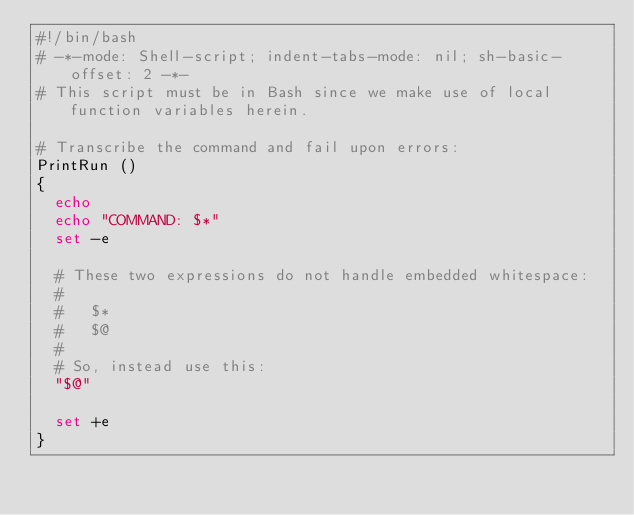<code> <loc_0><loc_0><loc_500><loc_500><_Bash_>#!/bin/bash
# -*-mode: Shell-script; indent-tabs-mode: nil; sh-basic-offset: 2 -*-
# This script must be in Bash since we make use of local function variables herein.

# Transcribe the command and fail upon errors:
PrintRun ()
{
  echo 
  echo "COMMAND: $*"
  set -e

  # These two expressions do not handle embedded whitespace:
  #
  #   $*
  #   $@
  #
  # So, instead use this:
  "$@"

  set +e
}
</code> 